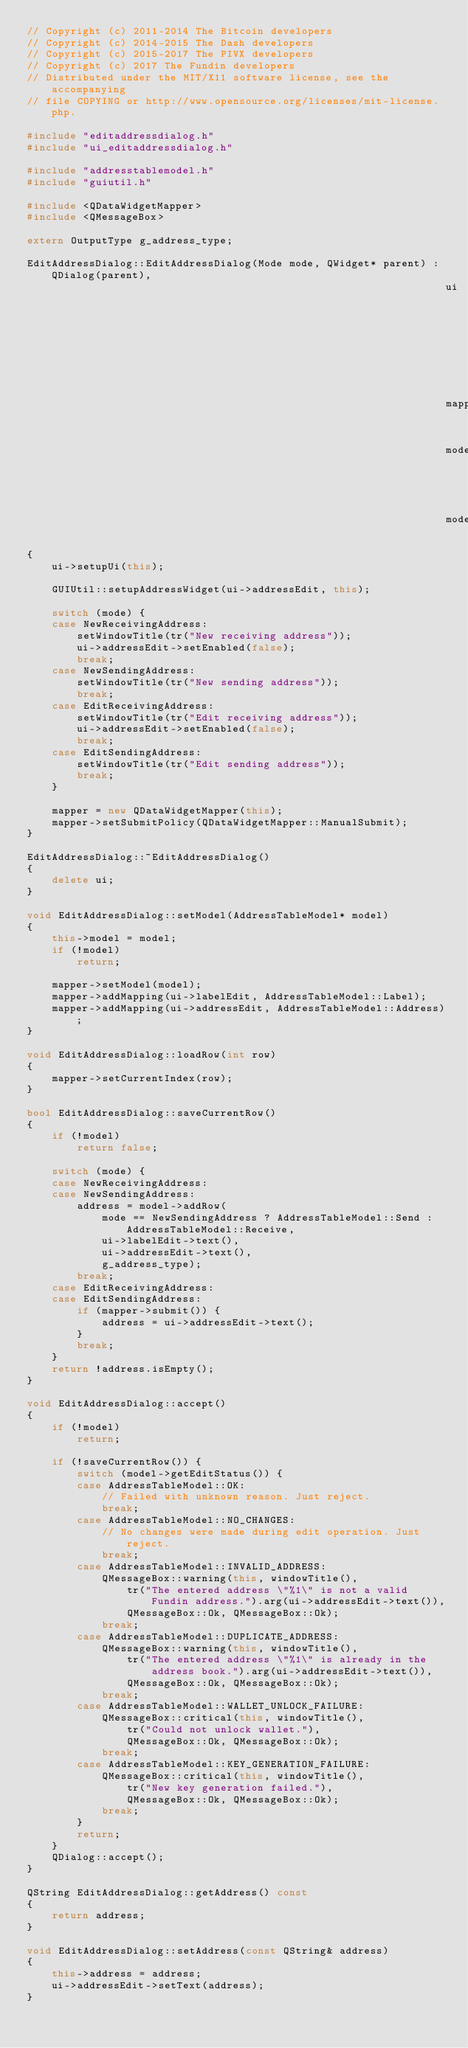<code> <loc_0><loc_0><loc_500><loc_500><_C++_>// Copyright (c) 2011-2014 The Bitcoin developers
// Copyright (c) 2014-2015 The Dash developers
// Copyright (c) 2015-2017 The PIVX developers
// Copyright (c) 2017 The Fundin developers
// Distributed under the MIT/X11 software license, see the accompanying
// file COPYING or http://www.opensource.org/licenses/mit-license.php.

#include "editaddressdialog.h"
#include "ui_editaddressdialog.h"

#include "addresstablemodel.h"
#include "guiutil.h"

#include <QDataWidgetMapper>
#include <QMessageBox>

extern OutputType g_address_type;

EditAddressDialog::EditAddressDialog(Mode mode, QWidget* parent) : QDialog(parent),
                                                                   ui(new Ui::EditAddressDialog),
                                                                   mapper(0),
                                                                   mode(mode),
                                                                   model(0)
{
    ui->setupUi(this);

    GUIUtil::setupAddressWidget(ui->addressEdit, this);

    switch (mode) {
    case NewReceivingAddress:
        setWindowTitle(tr("New receiving address"));
        ui->addressEdit->setEnabled(false);
        break;
    case NewSendingAddress:
        setWindowTitle(tr("New sending address"));
        break;
    case EditReceivingAddress:
        setWindowTitle(tr("Edit receiving address"));
        ui->addressEdit->setEnabled(false);
        break;
    case EditSendingAddress:
        setWindowTitle(tr("Edit sending address"));
        break;
    }

    mapper = new QDataWidgetMapper(this);
    mapper->setSubmitPolicy(QDataWidgetMapper::ManualSubmit);
}

EditAddressDialog::~EditAddressDialog()
{
    delete ui;
}

void EditAddressDialog::setModel(AddressTableModel* model)
{
    this->model = model;
    if (!model)
        return;

    mapper->setModel(model);
    mapper->addMapping(ui->labelEdit, AddressTableModel::Label);
    mapper->addMapping(ui->addressEdit, AddressTableModel::Address);
}

void EditAddressDialog::loadRow(int row)
{
    mapper->setCurrentIndex(row);
}

bool EditAddressDialog::saveCurrentRow()
{
    if (!model)
        return false;

    switch (mode) {
    case NewReceivingAddress:
    case NewSendingAddress:
        address = model->addRow(
            mode == NewSendingAddress ? AddressTableModel::Send : AddressTableModel::Receive,
            ui->labelEdit->text(),
            ui->addressEdit->text(),
            g_address_type);
        break;
    case EditReceivingAddress:
    case EditSendingAddress:
        if (mapper->submit()) {
            address = ui->addressEdit->text();
        }
        break;
    }
    return !address.isEmpty();
}

void EditAddressDialog::accept()
{
    if (!model)
        return;

    if (!saveCurrentRow()) {
        switch (model->getEditStatus()) {
        case AddressTableModel::OK:
            // Failed with unknown reason. Just reject.
            break;
        case AddressTableModel::NO_CHANGES:
            // No changes were made during edit operation. Just reject.
            break;
        case AddressTableModel::INVALID_ADDRESS:
            QMessageBox::warning(this, windowTitle(),
                tr("The entered address \"%1\" is not a valid Fundin address.").arg(ui->addressEdit->text()),
                QMessageBox::Ok, QMessageBox::Ok);
            break;
        case AddressTableModel::DUPLICATE_ADDRESS:
            QMessageBox::warning(this, windowTitle(),
                tr("The entered address \"%1\" is already in the address book.").arg(ui->addressEdit->text()),
                QMessageBox::Ok, QMessageBox::Ok);
            break;
        case AddressTableModel::WALLET_UNLOCK_FAILURE:
            QMessageBox::critical(this, windowTitle(),
                tr("Could not unlock wallet."),
                QMessageBox::Ok, QMessageBox::Ok);
            break;
        case AddressTableModel::KEY_GENERATION_FAILURE:
            QMessageBox::critical(this, windowTitle(),
                tr("New key generation failed."),
                QMessageBox::Ok, QMessageBox::Ok);
            break;
        }
        return;
    }
    QDialog::accept();
}

QString EditAddressDialog::getAddress() const
{
    return address;
}

void EditAddressDialog::setAddress(const QString& address)
{
    this->address = address;
    ui->addressEdit->setText(address);
}
</code> 